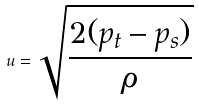<formula> <loc_0><loc_0><loc_500><loc_500>u = \sqrt { \frac { 2 ( p _ { t } - p _ { s } ) } { \rho } }</formula> 